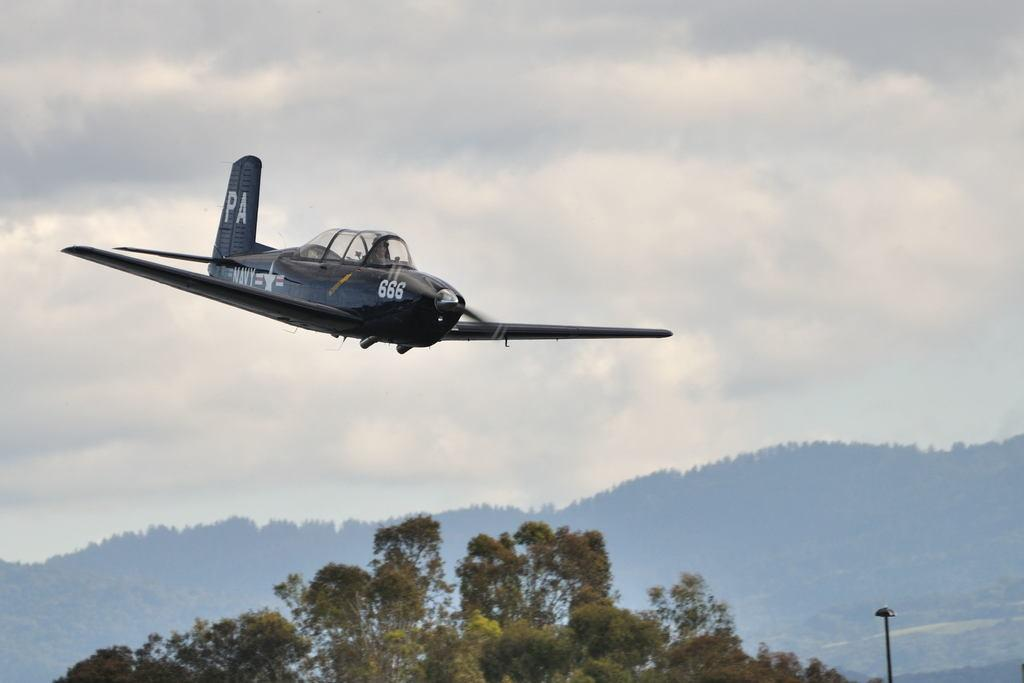<image>
Provide a brief description of the given image. A Navy airplane is decending over a copse of trees. 